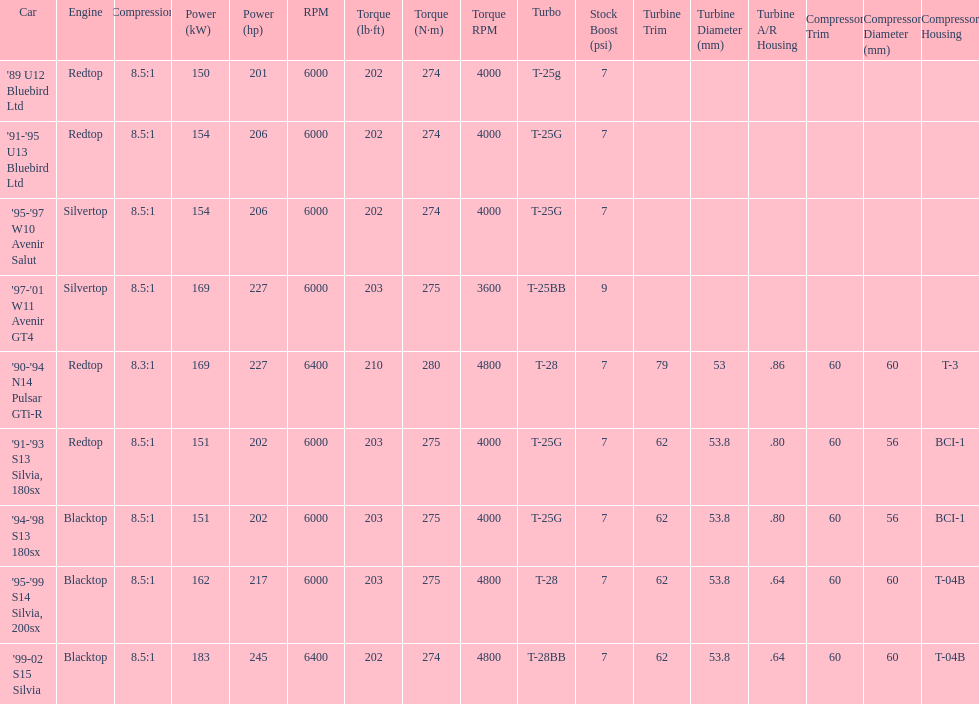Which engine has the smallest compression rate? '90-'94 N14 Pulsar GTi-R. 